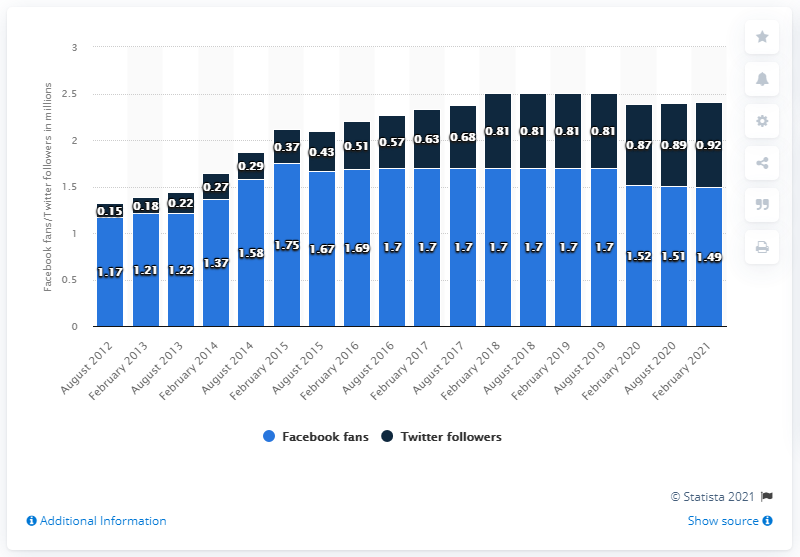Draw attention to some important aspects in this diagram. The Los Angeles Chargers' Facebook page was created in August 2012. As of February 2021, the number of Facebook followers of the Los Angeles Chargers had come to an end. As of February 2021, the San Diego Chargers football team had 1,490 Facebook followers. 